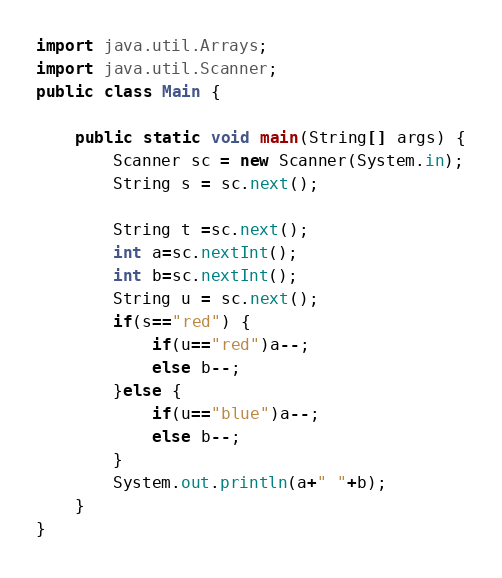Convert code to text. <code><loc_0><loc_0><loc_500><loc_500><_Java_>

import java.util.Arrays;
import java.util.Scanner;
public class Main {

	public static void main(String[] args) {
		Scanner sc = new Scanner(System.in);
		String s = sc.next();
		
		String t =sc.next();
		int a=sc.nextInt();
		int b=sc.nextInt();
		String u = sc.next();
		if(s=="red") {
			if(u=="red")a--;
			else b--;
		}else {
			if(u=="blue")a--;
			else b--;
		}
		System.out.println(a+" "+b);
	}
}</code> 